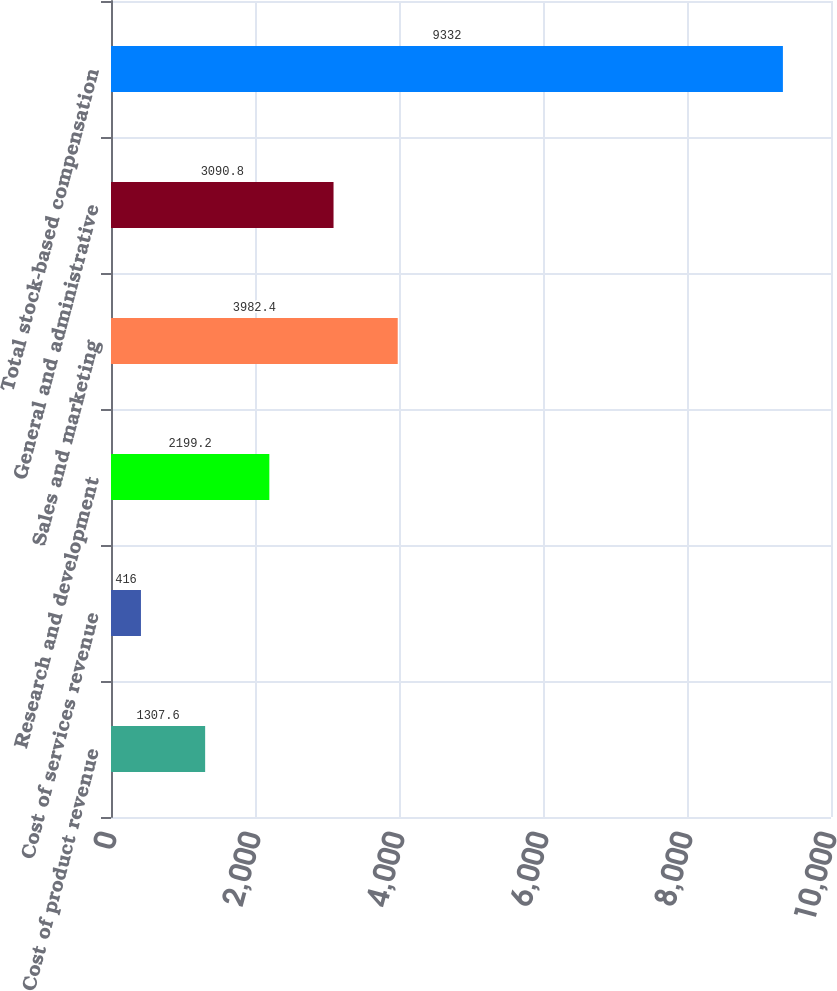<chart> <loc_0><loc_0><loc_500><loc_500><bar_chart><fcel>Cost of product revenue<fcel>Cost of services revenue<fcel>Research and development<fcel>Sales and marketing<fcel>General and administrative<fcel>Total stock-based compensation<nl><fcel>1307.6<fcel>416<fcel>2199.2<fcel>3982.4<fcel>3090.8<fcel>9332<nl></chart> 